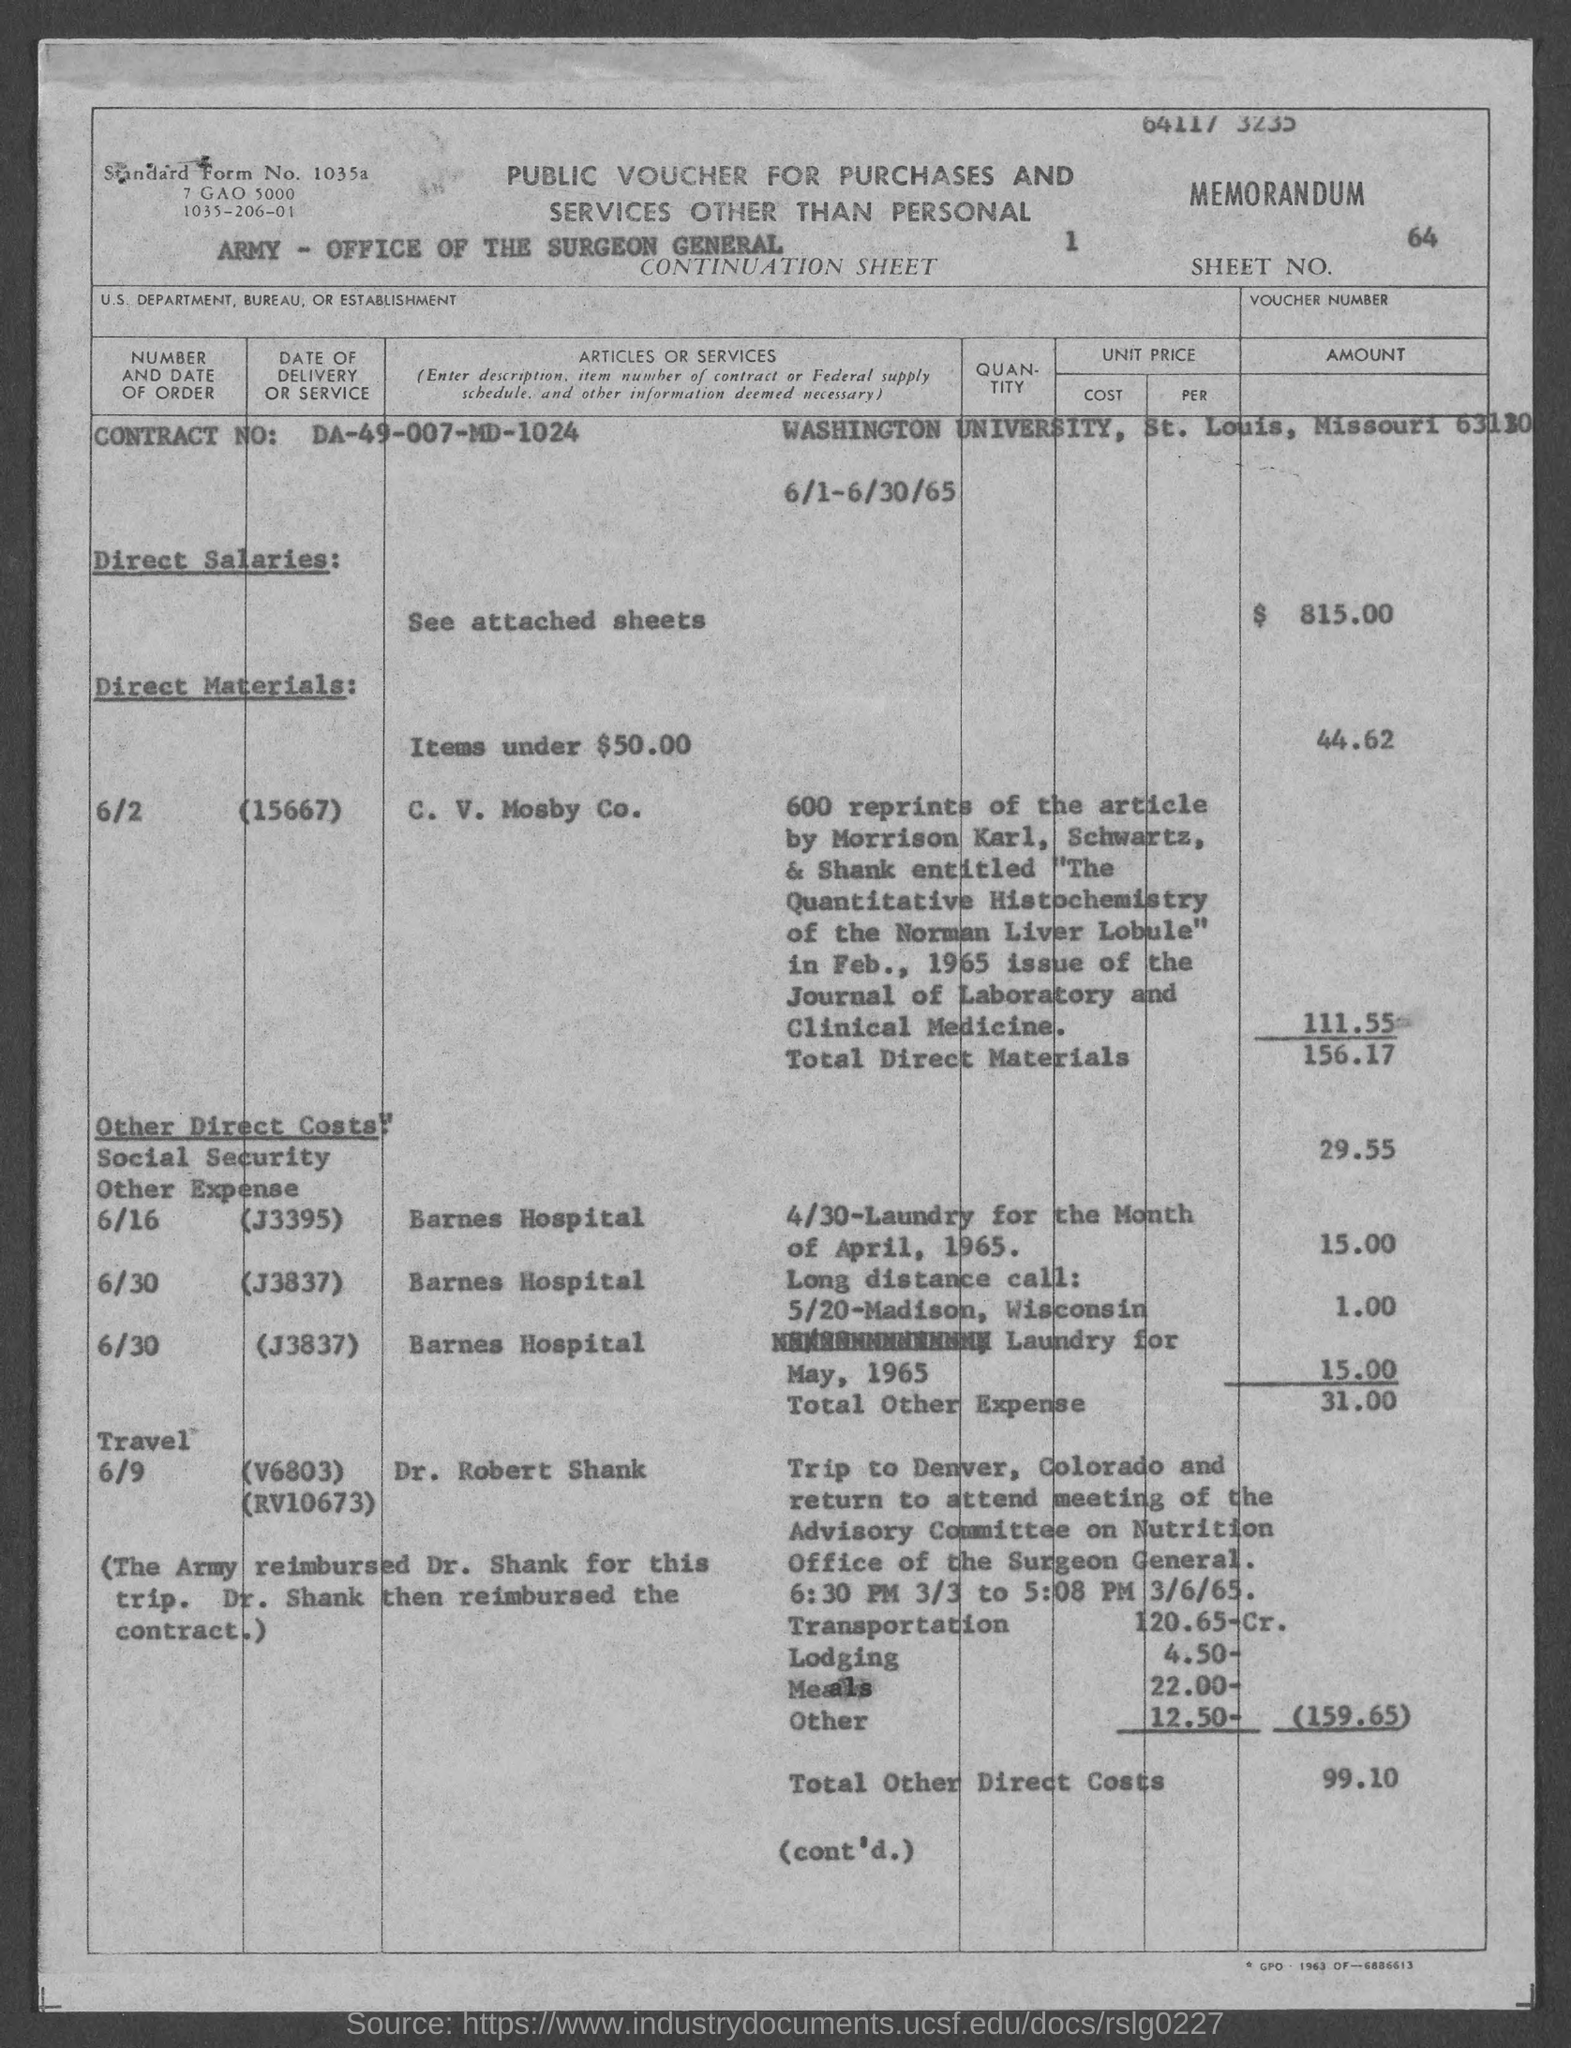What is the Sheet No.?
Your answer should be compact. 64. What is the Contract No.?
Make the answer very short. DA-49-007-MD-1024. What are the Direct Salaries?
Provide a short and direct response. $ 815.00. What is the total direct materials?
Ensure brevity in your answer.  156.17. What is the total Other Expense?
Offer a terse response. 31.00. What is the total Other Direct Costs?
Your response must be concise. 99.10. 